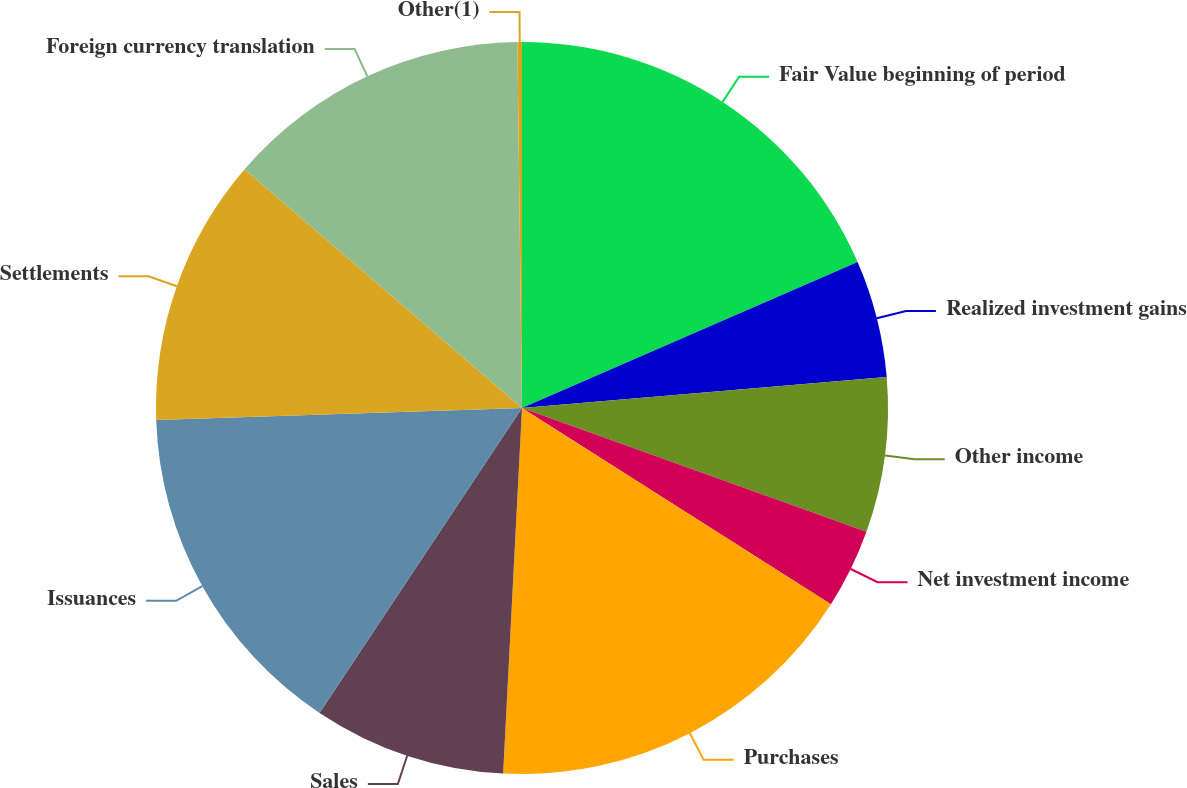<chart> <loc_0><loc_0><loc_500><loc_500><pie_chart><fcel>Fair Value beginning of period<fcel>Realized investment gains<fcel>Other income<fcel>Net investment income<fcel>Purchases<fcel>Sales<fcel>Issuances<fcel>Settlements<fcel>Foreign currency translation<fcel>Other(1)<nl><fcel>18.47%<fcel>5.18%<fcel>6.84%<fcel>3.52%<fcel>16.81%<fcel>8.51%<fcel>15.15%<fcel>11.83%<fcel>13.49%<fcel>0.2%<nl></chart> 